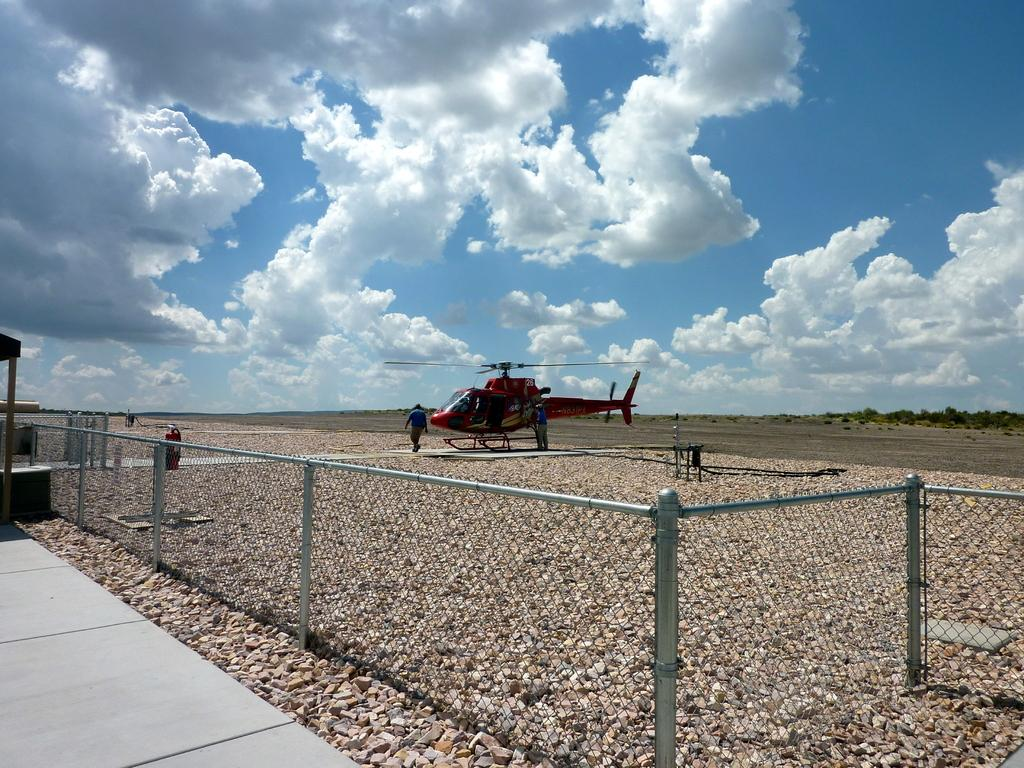Where was the image taken? The image is clicked outside. What is the main subject in the middle of the image? There is a helicopter in the middle of the image. Are there any people visible in the image? Yes, there are people standing in the middle of the image. What can be seen at the top of the image? The sky is visible at the top of the image. What is located at the bottom of the image? There is a fence at the bottom of the image. Can you see a snake slithering near the fence in the image? There is no snake present in the image; it only features a helicopter, people, the sky, and a fence. 